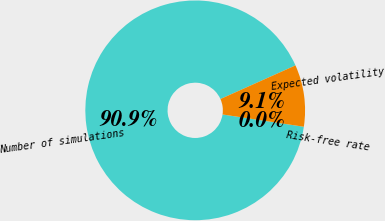Convert chart. <chart><loc_0><loc_0><loc_500><loc_500><pie_chart><fcel>Number of simulations<fcel>Expected volatility<fcel>Risk-free rate<nl><fcel>90.9%<fcel>9.09%<fcel>0.0%<nl></chart> 